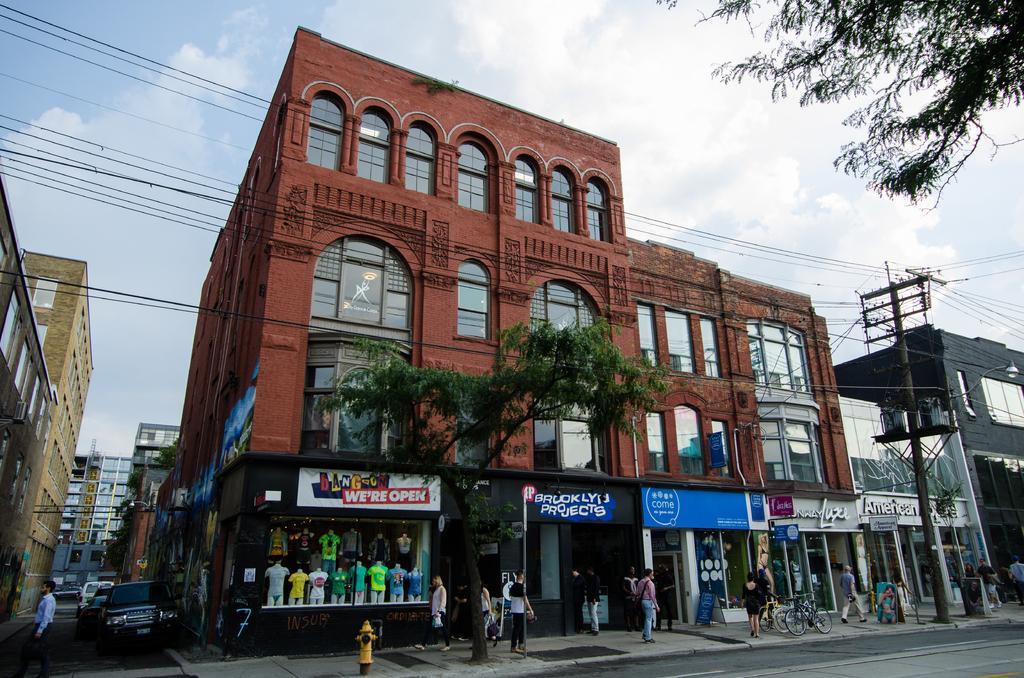Describe this image in one or two sentences. Few people are walking and few people standing. We can see yellow hydrant on the surface,tree,buildings,cars on the surface,road and sky. We can see current pole with wires. Right side of the image we can see tree. 